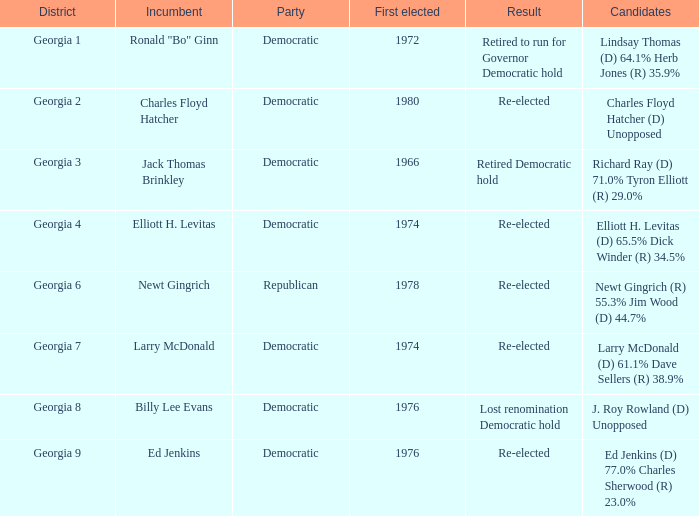Name the party of georgia 4 Democratic. 